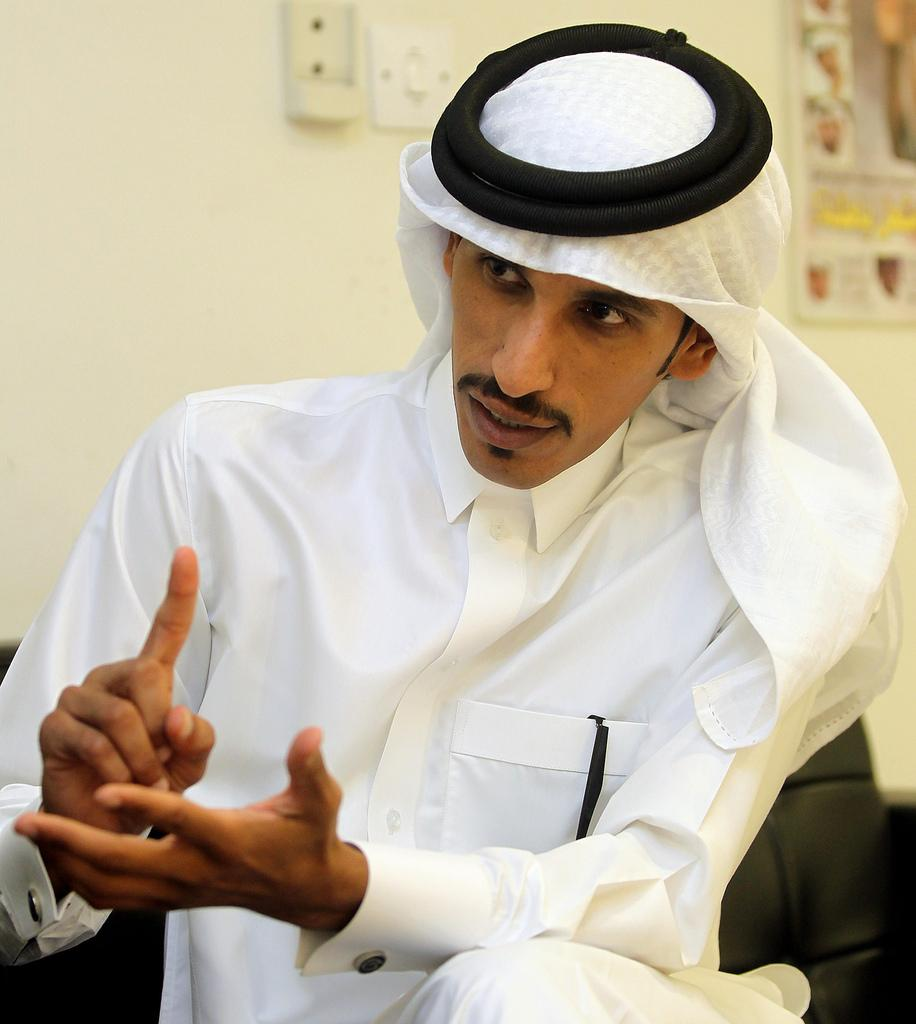What is the person in the image doing? There is a person sitting on a couch in the image. What can be seen on the wall in the image? There are objects on the wall in the image. What type of ring can be seen on the person's finger in the image? There is no ring visible on the person's finger in the image. How does the feather contribute to the person's hope in the image? There is no feather or mention of hope in the image. 